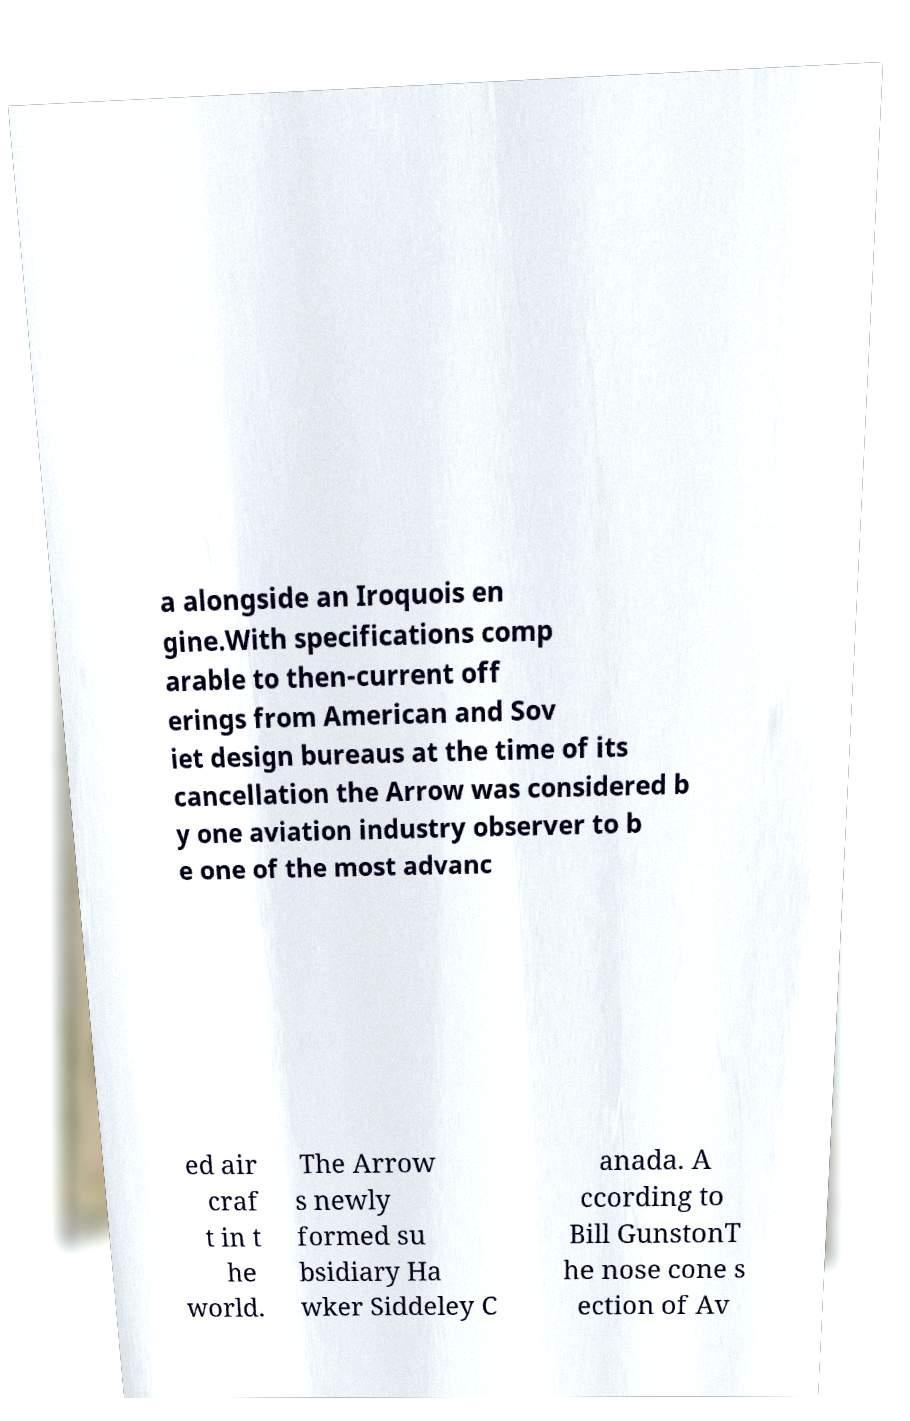Could you extract and type out the text from this image? a alongside an Iroquois en gine.With specifications comp arable to then-current off erings from American and Sov iet design bureaus at the time of its cancellation the Arrow was considered b y one aviation industry observer to b e one of the most advanc ed air craf t in t he world. The Arrow s newly formed su bsidiary Ha wker Siddeley C anada. A ccording to Bill GunstonT he nose cone s ection of Av 